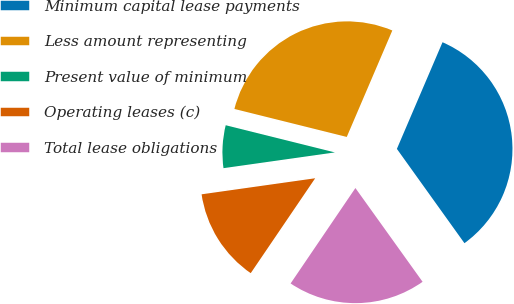Convert chart. <chart><loc_0><loc_0><loc_500><loc_500><pie_chart><fcel>Minimum capital lease payments<fcel>Less amount representing<fcel>Present value of minimum<fcel>Operating leases (c)<fcel>Total lease obligations<nl><fcel>33.67%<fcel>27.55%<fcel>6.12%<fcel>13.27%<fcel>19.39%<nl></chart> 